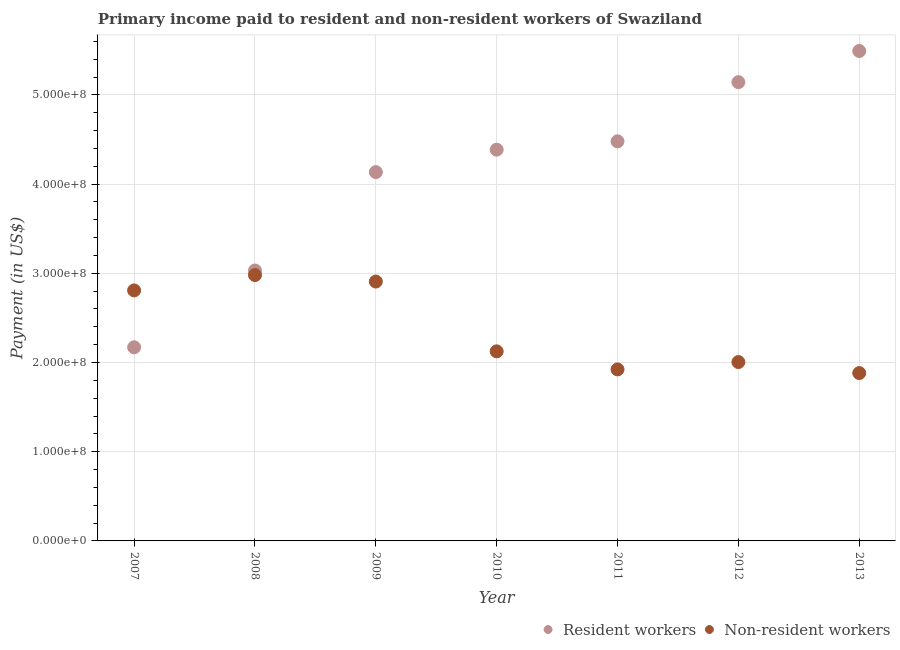How many different coloured dotlines are there?
Your answer should be compact. 2. Is the number of dotlines equal to the number of legend labels?
Your answer should be compact. Yes. What is the payment made to resident workers in 2011?
Offer a very short reply. 4.48e+08. Across all years, what is the maximum payment made to non-resident workers?
Offer a terse response. 2.98e+08. Across all years, what is the minimum payment made to non-resident workers?
Give a very brief answer. 1.88e+08. In which year was the payment made to non-resident workers minimum?
Your response must be concise. 2013. What is the total payment made to non-resident workers in the graph?
Give a very brief answer. 1.66e+09. What is the difference between the payment made to non-resident workers in 2008 and that in 2009?
Ensure brevity in your answer.  7.25e+06. What is the difference between the payment made to non-resident workers in 2010 and the payment made to resident workers in 2008?
Offer a terse response. -9.07e+07. What is the average payment made to resident workers per year?
Provide a short and direct response. 4.12e+08. In the year 2009, what is the difference between the payment made to resident workers and payment made to non-resident workers?
Your answer should be compact. 1.23e+08. In how many years, is the payment made to resident workers greater than 340000000 US$?
Your answer should be compact. 5. What is the ratio of the payment made to resident workers in 2009 to that in 2010?
Give a very brief answer. 0.94. What is the difference between the highest and the second highest payment made to non-resident workers?
Ensure brevity in your answer.  7.25e+06. What is the difference between the highest and the lowest payment made to resident workers?
Your response must be concise. 3.32e+08. Is the sum of the payment made to non-resident workers in 2007 and 2013 greater than the maximum payment made to resident workers across all years?
Your response must be concise. No. Is the payment made to non-resident workers strictly greater than the payment made to resident workers over the years?
Offer a terse response. No. Is the payment made to non-resident workers strictly less than the payment made to resident workers over the years?
Offer a very short reply. No. How many dotlines are there?
Keep it short and to the point. 2. What is the difference between two consecutive major ticks on the Y-axis?
Give a very brief answer. 1.00e+08. Does the graph contain any zero values?
Your answer should be very brief. No. Does the graph contain grids?
Make the answer very short. Yes. How many legend labels are there?
Offer a very short reply. 2. What is the title of the graph?
Offer a terse response. Primary income paid to resident and non-resident workers of Swaziland. Does "Export" appear as one of the legend labels in the graph?
Provide a short and direct response. No. What is the label or title of the Y-axis?
Make the answer very short. Payment (in US$). What is the Payment (in US$) in Resident workers in 2007?
Make the answer very short. 2.17e+08. What is the Payment (in US$) of Non-resident workers in 2007?
Ensure brevity in your answer.  2.81e+08. What is the Payment (in US$) in Resident workers in 2008?
Keep it short and to the point. 3.03e+08. What is the Payment (in US$) in Non-resident workers in 2008?
Ensure brevity in your answer.  2.98e+08. What is the Payment (in US$) of Resident workers in 2009?
Give a very brief answer. 4.13e+08. What is the Payment (in US$) in Non-resident workers in 2009?
Ensure brevity in your answer.  2.91e+08. What is the Payment (in US$) of Resident workers in 2010?
Give a very brief answer. 4.39e+08. What is the Payment (in US$) in Non-resident workers in 2010?
Make the answer very short. 2.13e+08. What is the Payment (in US$) of Resident workers in 2011?
Provide a succinct answer. 4.48e+08. What is the Payment (in US$) of Non-resident workers in 2011?
Your response must be concise. 1.92e+08. What is the Payment (in US$) in Resident workers in 2012?
Your response must be concise. 5.14e+08. What is the Payment (in US$) of Non-resident workers in 2012?
Your answer should be very brief. 2.01e+08. What is the Payment (in US$) of Resident workers in 2013?
Your response must be concise. 5.49e+08. What is the Payment (in US$) in Non-resident workers in 2013?
Ensure brevity in your answer.  1.88e+08. Across all years, what is the maximum Payment (in US$) of Resident workers?
Give a very brief answer. 5.49e+08. Across all years, what is the maximum Payment (in US$) in Non-resident workers?
Keep it short and to the point. 2.98e+08. Across all years, what is the minimum Payment (in US$) in Resident workers?
Make the answer very short. 2.17e+08. Across all years, what is the minimum Payment (in US$) of Non-resident workers?
Your response must be concise. 1.88e+08. What is the total Payment (in US$) of Resident workers in the graph?
Your response must be concise. 2.88e+09. What is the total Payment (in US$) in Non-resident workers in the graph?
Ensure brevity in your answer.  1.66e+09. What is the difference between the Payment (in US$) in Resident workers in 2007 and that in 2008?
Your answer should be very brief. -8.61e+07. What is the difference between the Payment (in US$) of Non-resident workers in 2007 and that in 2008?
Provide a succinct answer. -1.72e+07. What is the difference between the Payment (in US$) in Resident workers in 2007 and that in 2009?
Give a very brief answer. -1.96e+08. What is the difference between the Payment (in US$) in Non-resident workers in 2007 and that in 2009?
Keep it short and to the point. -9.94e+06. What is the difference between the Payment (in US$) in Resident workers in 2007 and that in 2010?
Make the answer very short. -2.22e+08. What is the difference between the Payment (in US$) in Non-resident workers in 2007 and that in 2010?
Offer a terse response. 6.83e+07. What is the difference between the Payment (in US$) in Resident workers in 2007 and that in 2011?
Your answer should be compact. -2.31e+08. What is the difference between the Payment (in US$) of Non-resident workers in 2007 and that in 2011?
Offer a terse response. 8.85e+07. What is the difference between the Payment (in US$) of Resident workers in 2007 and that in 2012?
Keep it short and to the point. -2.97e+08. What is the difference between the Payment (in US$) of Non-resident workers in 2007 and that in 2012?
Your response must be concise. 8.03e+07. What is the difference between the Payment (in US$) in Resident workers in 2007 and that in 2013?
Your response must be concise. -3.32e+08. What is the difference between the Payment (in US$) in Non-resident workers in 2007 and that in 2013?
Offer a terse response. 9.27e+07. What is the difference between the Payment (in US$) in Resident workers in 2008 and that in 2009?
Offer a terse response. -1.10e+08. What is the difference between the Payment (in US$) of Non-resident workers in 2008 and that in 2009?
Provide a short and direct response. 7.25e+06. What is the difference between the Payment (in US$) of Resident workers in 2008 and that in 2010?
Keep it short and to the point. -1.35e+08. What is the difference between the Payment (in US$) of Non-resident workers in 2008 and that in 2010?
Give a very brief answer. 8.55e+07. What is the difference between the Payment (in US$) of Resident workers in 2008 and that in 2011?
Give a very brief answer. -1.45e+08. What is the difference between the Payment (in US$) of Non-resident workers in 2008 and that in 2011?
Your response must be concise. 1.06e+08. What is the difference between the Payment (in US$) of Resident workers in 2008 and that in 2012?
Your answer should be compact. -2.11e+08. What is the difference between the Payment (in US$) in Non-resident workers in 2008 and that in 2012?
Make the answer very short. 9.75e+07. What is the difference between the Payment (in US$) in Resident workers in 2008 and that in 2013?
Make the answer very short. -2.46e+08. What is the difference between the Payment (in US$) of Non-resident workers in 2008 and that in 2013?
Your response must be concise. 1.10e+08. What is the difference between the Payment (in US$) in Resident workers in 2009 and that in 2010?
Ensure brevity in your answer.  -2.52e+07. What is the difference between the Payment (in US$) of Non-resident workers in 2009 and that in 2010?
Provide a short and direct response. 7.82e+07. What is the difference between the Payment (in US$) in Resident workers in 2009 and that in 2011?
Your answer should be compact. -3.45e+07. What is the difference between the Payment (in US$) in Non-resident workers in 2009 and that in 2011?
Your answer should be compact. 9.85e+07. What is the difference between the Payment (in US$) in Resident workers in 2009 and that in 2012?
Offer a very short reply. -1.01e+08. What is the difference between the Payment (in US$) in Non-resident workers in 2009 and that in 2012?
Offer a very short reply. 9.03e+07. What is the difference between the Payment (in US$) of Resident workers in 2009 and that in 2013?
Keep it short and to the point. -1.36e+08. What is the difference between the Payment (in US$) in Non-resident workers in 2009 and that in 2013?
Provide a succinct answer. 1.03e+08. What is the difference between the Payment (in US$) of Resident workers in 2010 and that in 2011?
Offer a terse response. -9.36e+06. What is the difference between the Payment (in US$) of Non-resident workers in 2010 and that in 2011?
Give a very brief answer. 2.02e+07. What is the difference between the Payment (in US$) of Resident workers in 2010 and that in 2012?
Offer a terse response. -7.57e+07. What is the difference between the Payment (in US$) in Non-resident workers in 2010 and that in 2012?
Give a very brief answer. 1.20e+07. What is the difference between the Payment (in US$) of Resident workers in 2010 and that in 2013?
Provide a succinct answer. -1.11e+08. What is the difference between the Payment (in US$) of Non-resident workers in 2010 and that in 2013?
Your response must be concise. 2.43e+07. What is the difference between the Payment (in US$) of Resident workers in 2011 and that in 2012?
Offer a very short reply. -6.63e+07. What is the difference between the Payment (in US$) in Non-resident workers in 2011 and that in 2012?
Ensure brevity in your answer.  -8.23e+06. What is the difference between the Payment (in US$) of Resident workers in 2011 and that in 2013?
Offer a terse response. -1.01e+08. What is the difference between the Payment (in US$) of Non-resident workers in 2011 and that in 2013?
Your answer should be very brief. 4.11e+06. What is the difference between the Payment (in US$) in Resident workers in 2012 and that in 2013?
Your response must be concise. -3.49e+07. What is the difference between the Payment (in US$) of Non-resident workers in 2012 and that in 2013?
Offer a very short reply. 1.23e+07. What is the difference between the Payment (in US$) of Resident workers in 2007 and the Payment (in US$) of Non-resident workers in 2008?
Give a very brief answer. -8.10e+07. What is the difference between the Payment (in US$) of Resident workers in 2007 and the Payment (in US$) of Non-resident workers in 2009?
Keep it short and to the point. -7.37e+07. What is the difference between the Payment (in US$) in Resident workers in 2007 and the Payment (in US$) in Non-resident workers in 2010?
Offer a very short reply. 4.53e+06. What is the difference between the Payment (in US$) of Resident workers in 2007 and the Payment (in US$) of Non-resident workers in 2011?
Give a very brief answer. 2.48e+07. What is the difference between the Payment (in US$) of Resident workers in 2007 and the Payment (in US$) of Non-resident workers in 2012?
Your answer should be very brief. 1.65e+07. What is the difference between the Payment (in US$) of Resident workers in 2007 and the Payment (in US$) of Non-resident workers in 2013?
Offer a terse response. 2.89e+07. What is the difference between the Payment (in US$) of Resident workers in 2008 and the Payment (in US$) of Non-resident workers in 2009?
Make the answer very short. 1.24e+07. What is the difference between the Payment (in US$) of Resident workers in 2008 and the Payment (in US$) of Non-resident workers in 2010?
Your answer should be compact. 9.07e+07. What is the difference between the Payment (in US$) in Resident workers in 2008 and the Payment (in US$) in Non-resident workers in 2011?
Your answer should be compact. 1.11e+08. What is the difference between the Payment (in US$) in Resident workers in 2008 and the Payment (in US$) in Non-resident workers in 2012?
Give a very brief answer. 1.03e+08. What is the difference between the Payment (in US$) in Resident workers in 2008 and the Payment (in US$) in Non-resident workers in 2013?
Your answer should be very brief. 1.15e+08. What is the difference between the Payment (in US$) in Resident workers in 2009 and the Payment (in US$) in Non-resident workers in 2010?
Your answer should be very brief. 2.01e+08. What is the difference between the Payment (in US$) of Resident workers in 2009 and the Payment (in US$) of Non-resident workers in 2011?
Provide a short and direct response. 2.21e+08. What is the difference between the Payment (in US$) of Resident workers in 2009 and the Payment (in US$) of Non-resident workers in 2012?
Make the answer very short. 2.13e+08. What is the difference between the Payment (in US$) of Resident workers in 2009 and the Payment (in US$) of Non-resident workers in 2013?
Keep it short and to the point. 2.25e+08. What is the difference between the Payment (in US$) of Resident workers in 2010 and the Payment (in US$) of Non-resident workers in 2011?
Keep it short and to the point. 2.46e+08. What is the difference between the Payment (in US$) of Resident workers in 2010 and the Payment (in US$) of Non-resident workers in 2012?
Make the answer very short. 2.38e+08. What is the difference between the Payment (in US$) in Resident workers in 2010 and the Payment (in US$) in Non-resident workers in 2013?
Offer a very short reply. 2.50e+08. What is the difference between the Payment (in US$) of Resident workers in 2011 and the Payment (in US$) of Non-resident workers in 2012?
Your answer should be very brief. 2.47e+08. What is the difference between the Payment (in US$) in Resident workers in 2011 and the Payment (in US$) in Non-resident workers in 2013?
Your answer should be compact. 2.60e+08. What is the difference between the Payment (in US$) of Resident workers in 2012 and the Payment (in US$) of Non-resident workers in 2013?
Offer a very short reply. 3.26e+08. What is the average Payment (in US$) of Resident workers per year?
Give a very brief answer. 4.12e+08. What is the average Payment (in US$) of Non-resident workers per year?
Offer a terse response. 2.38e+08. In the year 2007, what is the difference between the Payment (in US$) of Resident workers and Payment (in US$) of Non-resident workers?
Give a very brief answer. -6.38e+07. In the year 2008, what is the difference between the Payment (in US$) of Resident workers and Payment (in US$) of Non-resident workers?
Offer a very short reply. 5.16e+06. In the year 2009, what is the difference between the Payment (in US$) in Resident workers and Payment (in US$) in Non-resident workers?
Your answer should be compact. 1.23e+08. In the year 2010, what is the difference between the Payment (in US$) in Resident workers and Payment (in US$) in Non-resident workers?
Give a very brief answer. 2.26e+08. In the year 2011, what is the difference between the Payment (in US$) of Resident workers and Payment (in US$) of Non-resident workers?
Your answer should be very brief. 2.56e+08. In the year 2012, what is the difference between the Payment (in US$) in Resident workers and Payment (in US$) in Non-resident workers?
Keep it short and to the point. 3.14e+08. In the year 2013, what is the difference between the Payment (in US$) in Resident workers and Payment (in US$) in Non-resident workers?
Make the answer very short. 3.61e+08. What is the ratio of the Payment (in US$) of Resident workers in 2007 to that in 2008?
Provide a succinct answer. 0.72. What is the ratio of the Payment (in US$) in Non-resident workers in 2007 to that in 2008?
Ensure brevity in your answer.  0.94. What is the ratio of the Payment (in US$) in Resident workers in 2007 to that in 2009?
Offer a very short reply. 0.53. What is the ratio of the Payment (in US$) of Non-resident workers in 2007 to that in 2009?
Keep it short and to the point. 0.97. What is the ratio of the Payment (in US$) in Resident workers in 2007 to that in 2010?
Give a very brief answer. 0.49. What is the ratio of the Payment (in US$) in Non-resident workers in 2007 to that in 2010?
Keep it short and to the point. 1.32. What is the ratio of the Payment (in US$) in Resident workers in 2007 to that in 2011?
Offer a terse response. 0.48. What is the ratio of the Payment (in US$) in Non-resident workers in 2007 to that in 2011?
Your answer should be very brief. 1.46. What is the ratio of the Payment (in US$) of Resident workers in 2007 to that in 2012?
Provide a short and direct response. 0.42. What is the ratio of the Payment (in US$) of Non-resident workers in 2007 to that in 2012?
Offer a terse response. 1.4. What is the ratio of the Payment (in US$) of Resident workers in 2007 to that in 2013?
Your answer should be compact. 0.4. What is the ratio of the Payment (in US$) in Non-resident workers in 2007 to that in 2013?
Make the answer very short. 1.49. What is the ratio of the Payment (in US$) of Resident workers in 2008 to that in 2009?
Provide a short and direct response. 0.73. What is the ratio of the Payment (in US$) of Non-resident workers in 2008 to that in 2009?
Keep it short and to the point. 1.02. What is the ratio of the Payment (in US$) in Resident workers in 2008 to that in 2010?
Offer a very short reply. 0.69. What is the ratio of the Payment (in US$) of Non-resident workers in 2008 to that in 2010?
Offer a very short reply. 1.4. What is the ratio of the Payment (in US$) of Resident workers in 2008 to that in 2011?
Provide a short and direct response. 0.68. What is the ratio of the Payment (in US$) of Non-resident workers in 2008 to that in 2011?
Give a very brief answer. 1.55. What is the ratio of the Payment (in US$) in Resident workers in 2008 to that in 2012?
Ensure brevity in your answer.  0.59. What is the ratio of the Payment (in US$) in Non-resident workers in 2008 to that in 2012?
Your answer should be compact. 1.49. What is the ratio of the Payment (in US$) of Resident workers in 2008 to that in 2013?
Provide a succinct answer. 0.55. What is the ratio of the Payment (in US$) of Non-resident workers in 2008 to that in 2013?
Your answer should be very brief. 1.58. What is the ratio of the Payment (in US$) of Resident workers in 2009 to that in 2010?
Provide a short and direct response. 0.94. What is the ratio of the Payment (in US$) of Non-resident workers in 2009 to that in 2010?
Offer a very short reply. 1.37. What is the ratio of the Payment (in US$) of Resident workers in 2009 to that in 2011?
Your answer should be very brief. 0.92. What is the ratio of the Payment (in US$) of Non-resident workers in 2009 to that in 2011?
Your answer should be compact. 1.51. What is the ratio of the Payment (in US$) of Resident workers in 2009 to that in 2012?
Make the answer very short. 0.8. What is the ratio of the Payment (in US$) of Non-resident workers in 2009 to that in 2012?
Provide a succinct answer. 1.45. What is the ratio of the Payment (in US$) in Resident workers in 2009 to that in 2013?
Provide a short and direct response. 0.75. What is the ratio of the Payment (in US$) in Non-resident workers in 2009 to that in 2013?
Offer a very short reply. 1.55. What is the ratio of the Payment (in US$) of Resident workers in 2010 to that in 2011?
Provide a short and direct response. 0.98. What is the ratio of the Payment (in US$) of Non-resident workers in 2010 to that in 2011?
Keep it short and to the point. 1.11. What is the ratio of the Payment (in US$) of Resident workers in 2010 to that in 2012?
Offer a terse response. 0.85. What is the ratio of the Payment (in US$) of Non-resident workers in 2010 to that in 2012?
Ensure brevity in your answer.  1.06. What is the ratio of the Payment (in US$) in Resident workers in 2010 to that in 2013?
Your answer should be very brief. 0.8. What is the ratio of the Payment (in US$) of Non-resident workers in 2010 to that in 2013?
Your response must be concise. 1.13. What is the ratio of the Payment (in US$) of Resident workers in 2011 to that in 2012?
Give a very brief answer. 0.87. What is the ratio of the Payment (in US$) in Non-resident workers in 2011 to that in 2012?
Offer a very short reply. 0.96. What is the ratio of the Payment (in US$) in Resident workers in 2011 to that in 2013?
Provide a short and direct response. 0.82. What is the ratio of the Payment (in US$) of Non-resident workers in 2011 to that in 2013?
Your answer should be very brief. 1.02. What is the ratio of the Payment (in US$) of Resident workers in 2012 to that in 2013?
Ensure brevity in your answer.  0.94. What is the ratio of the Payment (in US$) in Non-resident workers in 2012 to that in 2013?
Offer a terse response. 1.07. What is the difference between the highest and the second highest Payment (in US$) of Resident workers?
Your answer should be compact. 3.49e+07. What is the difference between the highest and the second highest Payment (in US$) of Non-resident workers?
Keep it short and to the point. 7.25e+06. What is the difference between the highest and the lowest Payment (in US$) in Resident workers?
Ensure brevity in your answer.  3.32e+08. What is the difference between the highest and the lowest Payment (in US$) in Non-resident workers?
Offer a terse response. 1.10e+08. 